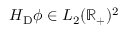<formula> <loc_0><loc_0><loc_500><loc_500>H _ { D } \phi \in L _ { 2 } ( \mathbb { R } _ { + } ) ^ { 2 }</formula> 